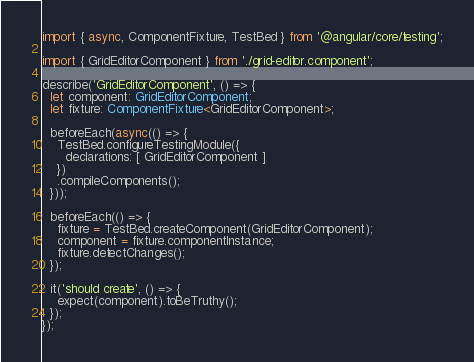<code> <loc_0><loc_0><loc_500><loc_500><_TypeScript_>import { async, ComponentFixture, TestBed } from '@angular/core/testing';

import { GridEditorComponent } from './grid-editor.component';

describe('GridEditorComponent', () => {
  let component: GridEditorComponent;
  let fixture: ComponentFixture<GridEditorComponent>;

  beforeEach(async(() => {
    TestBed.configureTestingModule({
      declarations: [ GridEditorComponent ]
    })
    .compileComponents();
  }));

  beforeEach(() => {
    fixture = TestBed.createComponent(GridEditorComponent);
    component = fixture.componentInstance;
    fixture.detectChanges();
  });

  it('should create', () => {
    expect(component).toBeTruthy();
  });
});
</code> 